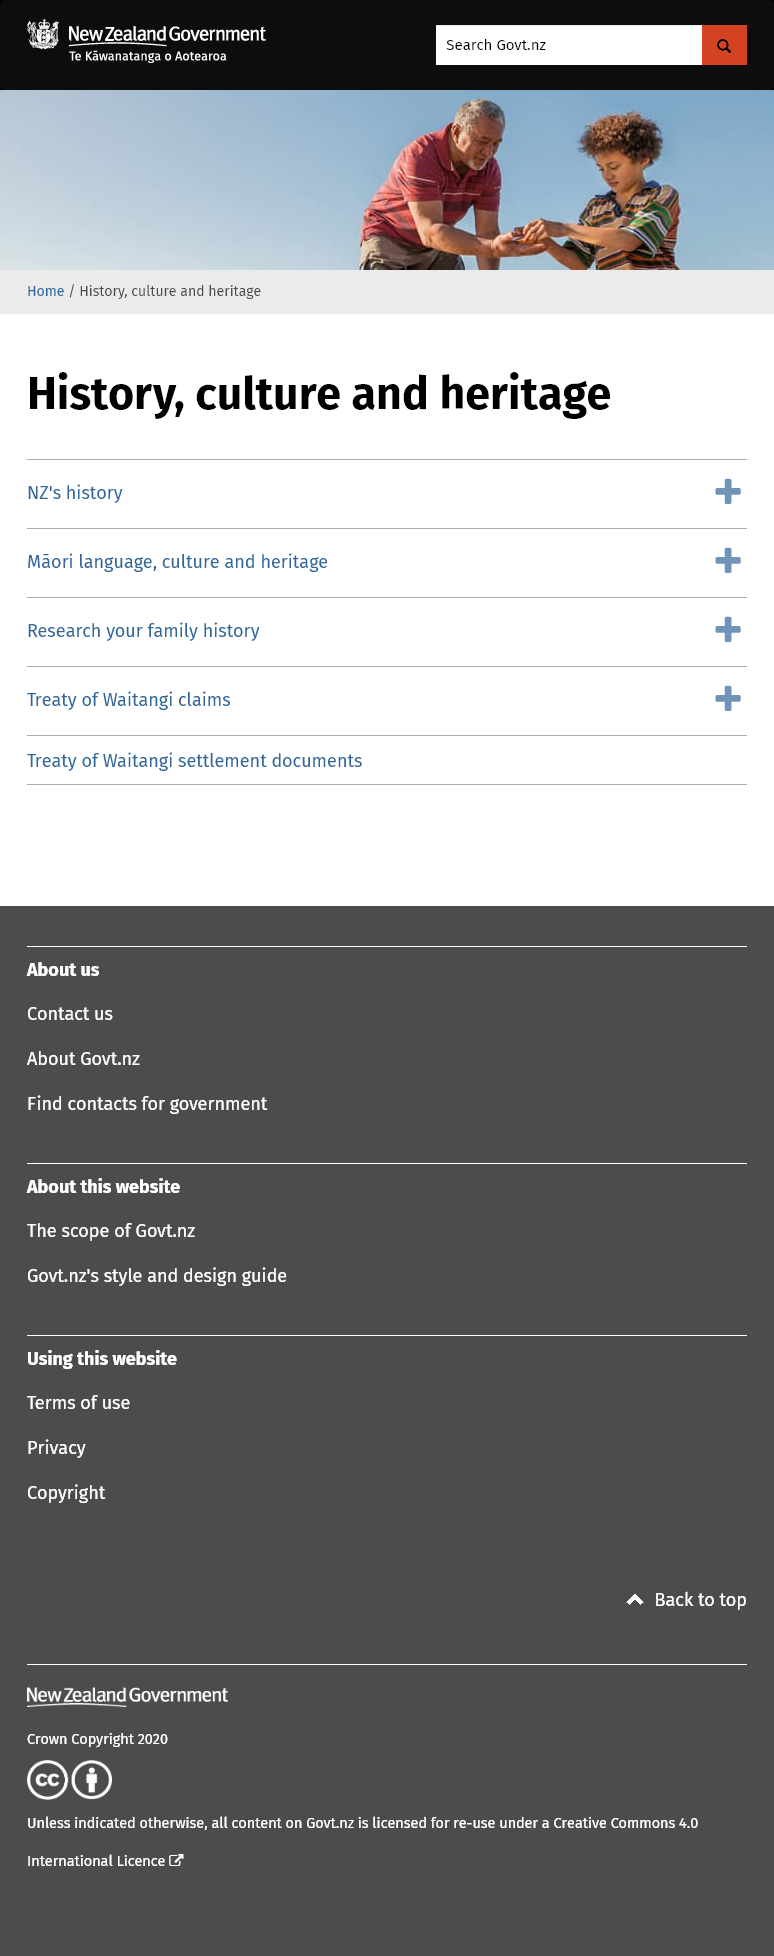List a handful of essential elements in this visual. The category of 'History, culture and heritage' includes 'Research your family history.' The categorization of 'Research your family history' is under 'History, culture and heritage'. Yes, 'NZ's history' is categorised under 'History, culture and heritage' in New Zealand. 